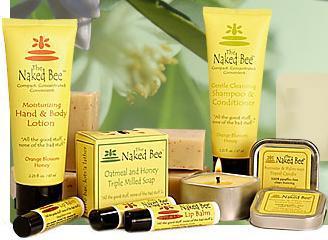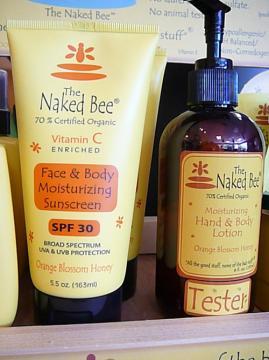The first image is the image on the left, the second image is the image on the right. For the images displayed, is the sentence "Each image includes yellow tubes that stand on flat black flip-top caps, but only the right image includes a dark brown bottle with a black pump top." factually correct? Answer yes or no. Yes. The first image is the image on the left, the second image is the image on the right. Considering the images on both sides, is "The left and right image contains a total of four squeeze bottles and at least one chapstick." valid? Answer yes or no. Yes. 